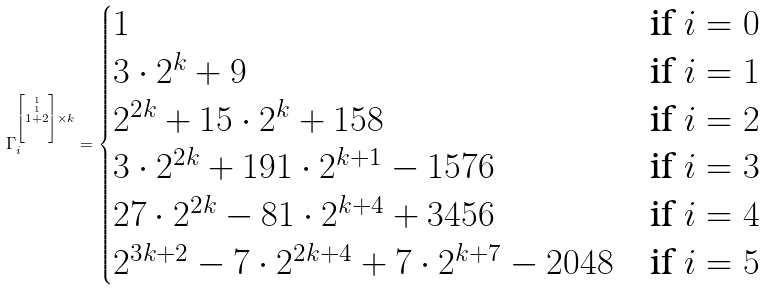Convert formula to latex. <formula><loc_0><loc_0><loc_500><loc_500>\Gamma _ { i } ^ { \left [ \stackrel { 1 } { \stackrel { 1 } { 1 + 2 } } \right ] \times k } = \begin{cases} 1 & \text {if } i = 0 \\ 3 \cdot 2 ^ { k } + 9 & \text {if } i = 1 \\ 2 ^ { 2 k } + 1 5 \cdot 2 ^ { k } + 1 5 8 & \text {if  } i = 2 \\ 3 \cdot 2 ^ { 2 k } + 1 9 1 \cdot 2 ^ { k + 1 } - 1 5 7 6 & \text {if  } i = 3 \\ 2 7 \cdot 2 ^ { 2 k } - 8 1 \cdot 2 ^ { k + 4 } + 3 4 5 6 & \text {if  } i = 4 \\ 2 ^ { 3 k + 2 } - 7 \cdot 2 ^ { 2 k + 4 } + 7 \cdot 2 ^ { k + 7 } - 2 0 4 8 & \text {if  } i = 5 \end{cases}</formula> 